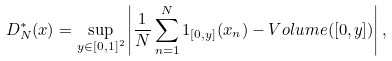Convert formula to latex. <formula><loc_0><loc_0><loc_500><loc_500>D _ { N } ^ { * } ( x ) = \sup _ { y \in [ 0 , 1 ] ^ { 2 } } \left | \frac { 1 } { N } \sum _ { n = 1 } ^ { N } 1 _ { [ 0 , y ] } ( x _ { n } ) - V o l u m e ( [ 0 , y ] ) \right | ,</formula> 